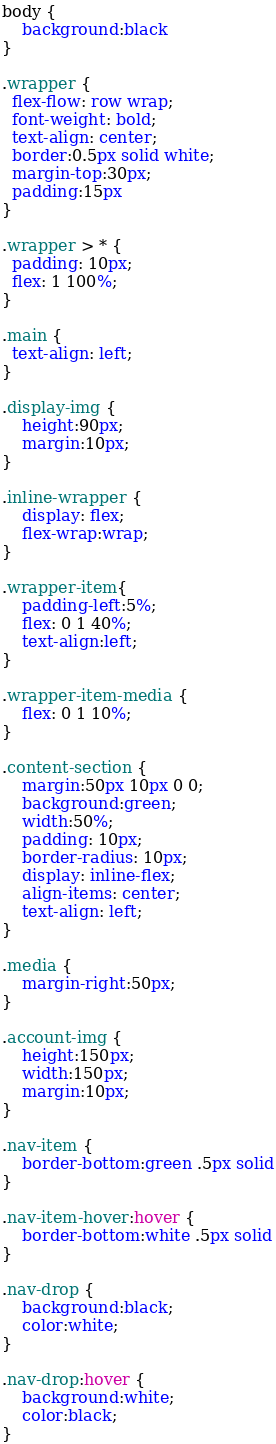Convert code to text. <code><loc_0><loc_0><loc_500><loc_500><_CSS_>body {
    background:black
}

.wrapper {
  flex-flow: row wrap;
  font-weight: bold;
  text-align: center;
  border:0.5px solid white;
  margin-top:30px;
  padding:15px
}

.wrapper > * {
  padding: 10px;
  flex: 1 100%;
}

.main {
  text-align: left;
}

.display-img {
    height:90px;
    margin:10px;
}

.inline-wrapper {
    display: flex;
    flex-wrap:wrap;
}

.wrapper-item{
    padding-left:5%;
    flex: 0 1 40%;
    text-align:left;
}

.wrapper-item-media {
    flex: 0 1 10%;
}

.content-section {
    margin:50px 10px 0 0;
    background:green;
    width:50%;
    padding: 10px;
    border-radius: 10px;
    display: inline-flex;
    align-items: center;
    text-align: left;
}

.media {
    margin-right:50px;
}

.account-img {
    height:150px;
    width:150px;
    margin:10px;
}

.nav-item {
    border-bottom:green .5px solid
}

.nav-item-hover:hover {
    border-bottom:white .5px solid
}

.nav-drop {
    background:black;
    color:white;
}

.nav-drop:hover {
    background:white;
    color:black;
}</code> 